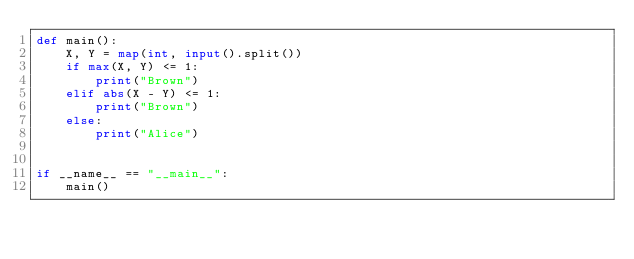<code> <loc_0><loc_0><loc_500><loc_500><_Python_>def main():
    X, Y = map(int, input().split())
    if max(X, Y) <= 1:
        print("Brown")
    elif abs(X - Y) <= 1:
        print("Brown")
    else:
        print("Alice")


if __name__ == "__main__":
    main()
</code> 